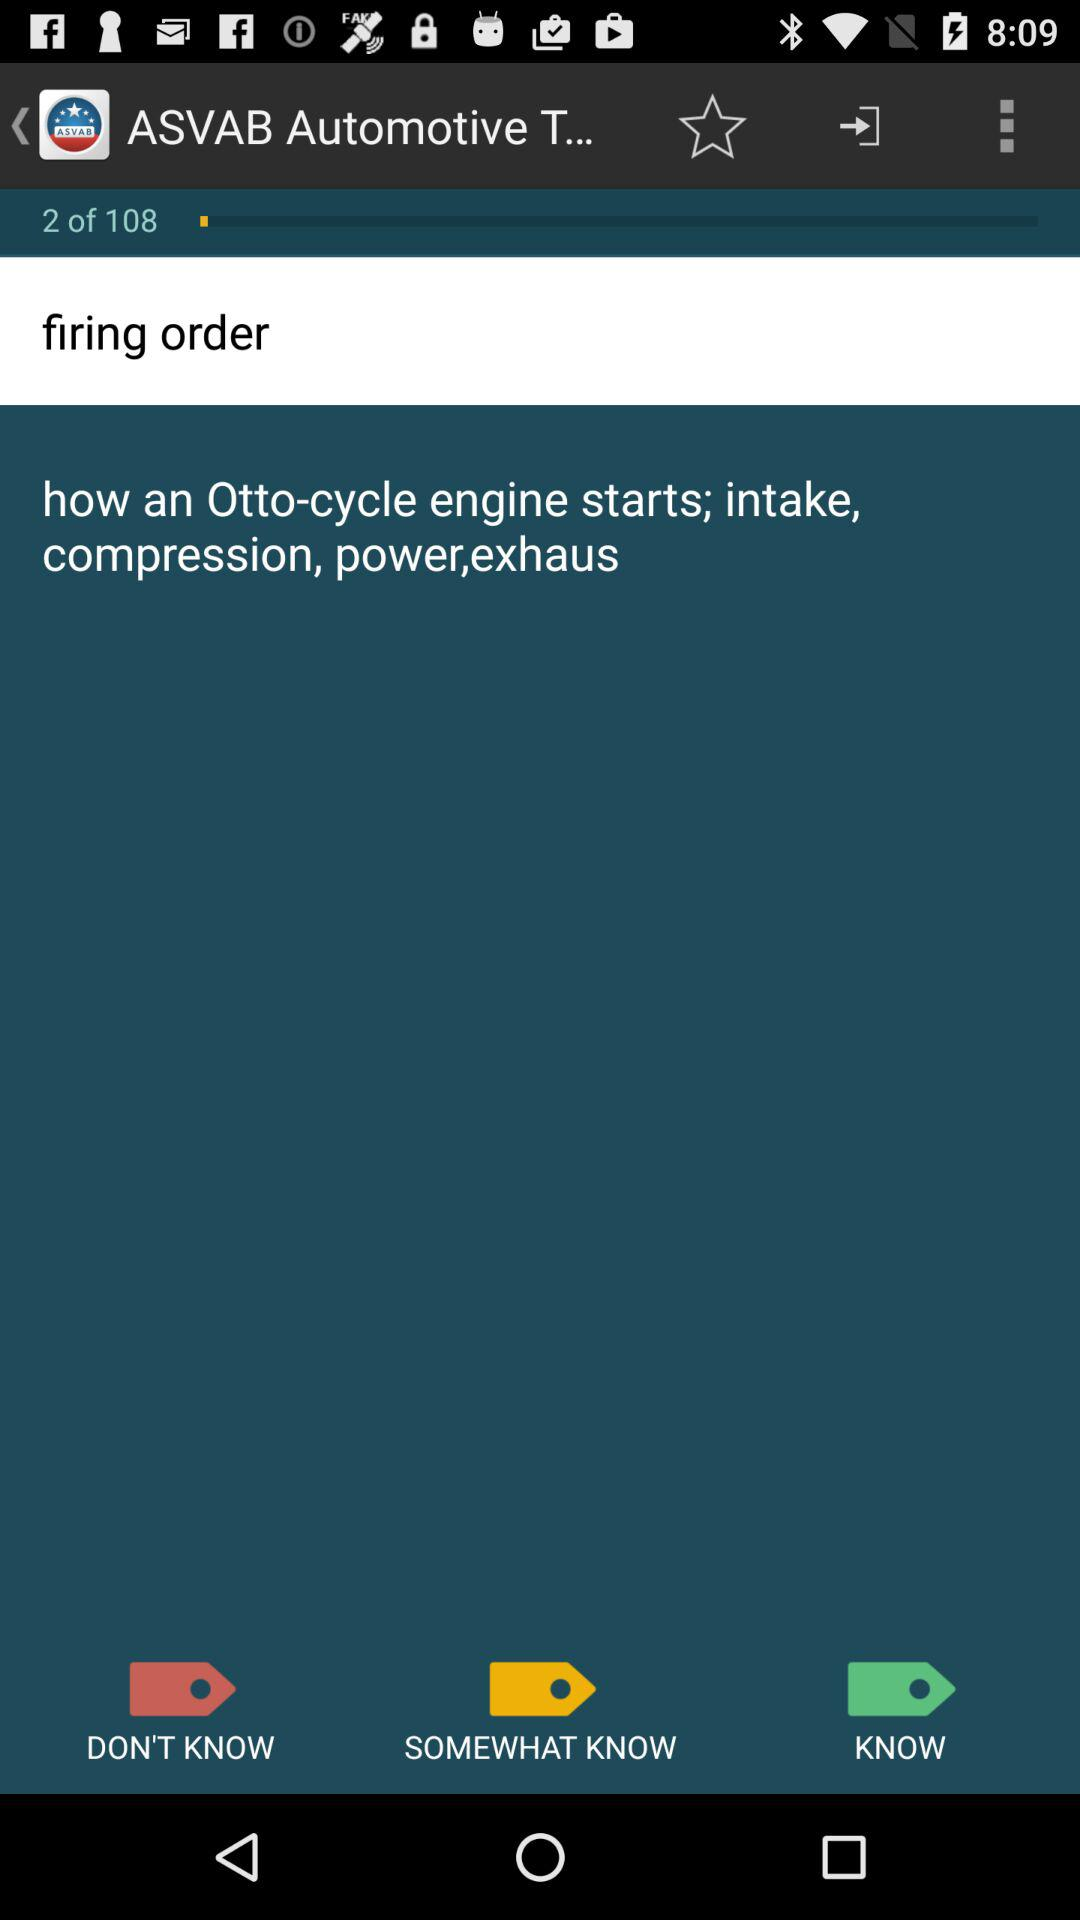What is the writing in the search box?
When the provided information is insufficient, respond with <no answer>. <no answer> 